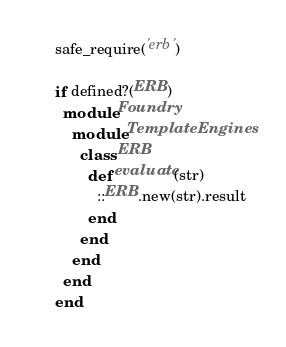Convert code to text. <code><loc_0><loc_0><loc_500><loc_500><_Ruby_>safe_require('erb')

if defined?(ERB)
  module Foundry
    module TemplateEngines
      class ERB
        def evaluate(str)
          ::ERB.new(str).result
        end
      end
    end
  end
end
</code> 